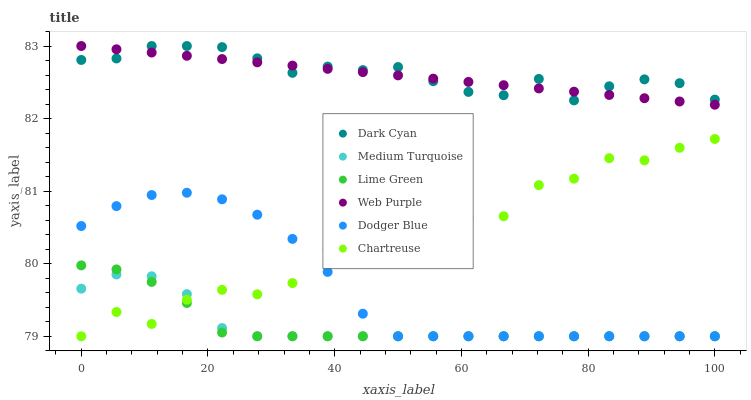Does Lime Green have the minimum area under the curve?
Answer yes or no. Yes. Does Dark Cyan have the maximum area under the curve?
Answer yes or no. Yes. Does Web Purple have the minimum area under the curve?
Answer yes or no. No. Does Web Purple have the maximum area under the curve?
Answer yes or no. No. Is Web Purple the smoothest?
Answer yes or no. Yes. Is Chartreuse the roughest?
Answer yes or no. Yes. Is Dodger Blue the smoothest?
Answer yes or no. No. Is Dodger Blue the roughest?
Answer yes or no. No. Does Chartreuse have the lowest value?
Answer yes or no. Yes. Does Web Purple have the lowest value?
Answer yes or no. No. Does Dark Cyan have the highest value?
Answer yes or no. Yes. Does Dodger Blue have the highest value?
Answer yes or no. No. Is Lime Green less than Web Purple?
Answer yes or no. Yes. Is Web Purple greater than Chartreuse?
Answer yes or no. Yes. Does Chartreuse intersect Dodger Blue?
Answer yes or no. Yes. Is Chartreuse less than Dodger Blue?
Answer yes or no. No. Is Chartreuse greater than Dodger Blue?
Answer yes or no. No. Does Lime Green intersect Web Purple?
Answer yes or no. No. 